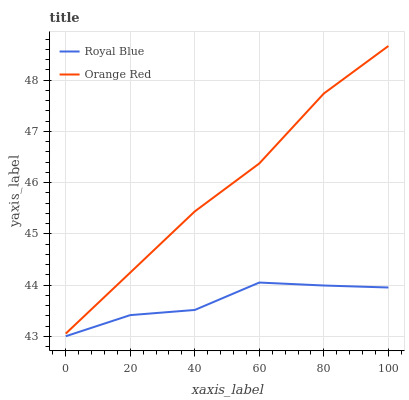Does Royal Blue have the minimum area under the curve?
Answer yes or no. Yes. Does Orange Red have the maximum area under the curve?
Answer yes or no. Yes. Does Orange Red have the minimum area under the curve?
Answer yes or no. No. Is Orange Red the smoothest?
Answer yes or no. Yes. Is Royal Blue the roughest?
Answer yes or no. Yes. Is Orange Red the roughest?
Answer yes or no. No. Does Royal Blue have the lowest value?
Answer yes or no. Yes. Does Orange Red have the lowest value?
Answer yes or no. No. Does Orange Red have the highest value?
Answer yes or no. Yes. Is Royal Blue less than Orange Red?
Answer yes or no. Yes. Is Orange Red greater than Royal Blue?
Answer yes or no. Yes. Does Royal Blue intersect Orange Red?
Answer yes or no. No. 